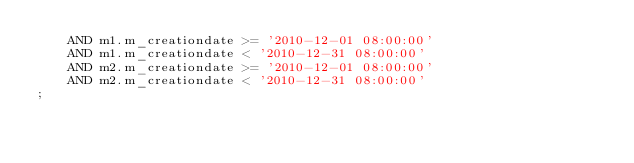Convert code to text. <code><loc_0><loc_0><loc_500><loc_500><_SQL_>    AND m1.m_creationdate >= '2010-12-01 08:00:00'
    AND m1.m_creationdate < '2010-12-31 08:00:00'
    AND m2.m_creationdate >= '2010-12-01 08:00:00'
    AND m2.m_creationdate < '2010-12-31 08:00:00'
;</code> 